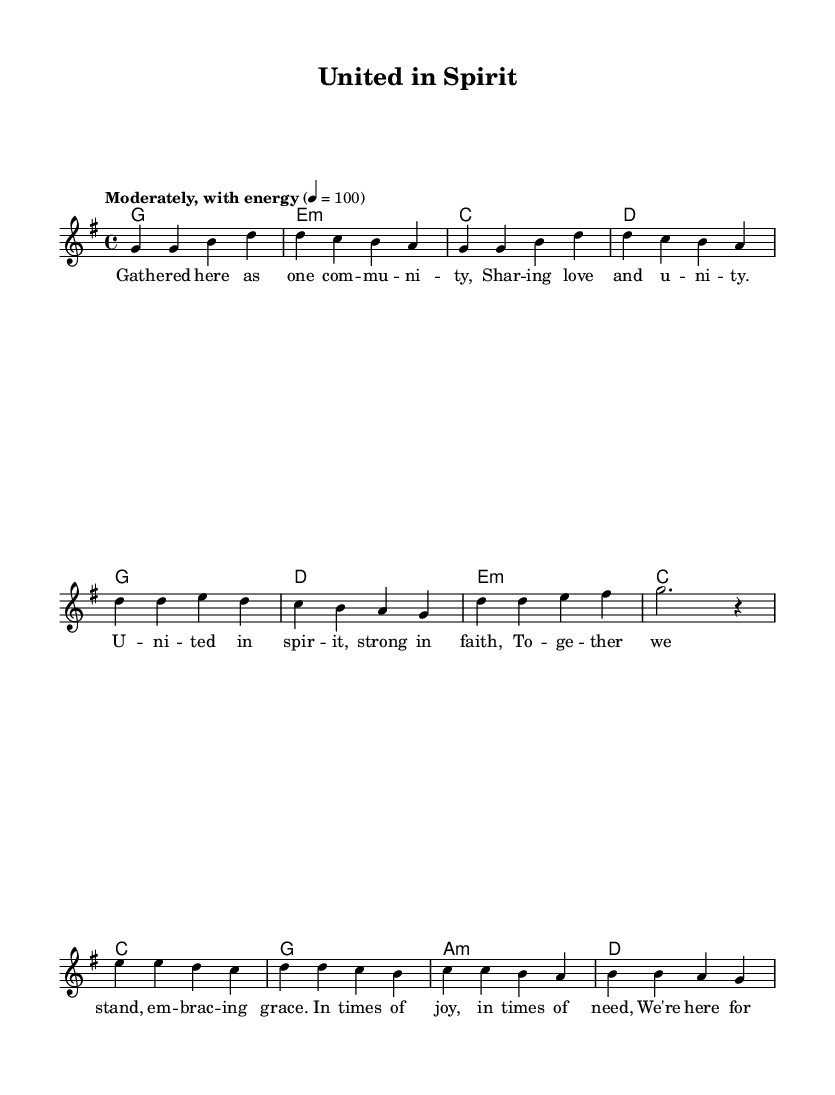What is the key signature of this music? The key signature is G major, which has one sharp (F#).
Answer: G major What is the time signature of this piece? The time signature is 4/4, indicating four beats per measure.
Answer: 4/4 What is the tempo marking for this piece? The tempo marking indicates a moderately energetic pace of 100 beats per minute.
Answer: Moderately, with energy How many measures are there in the verse? There are four measures in the verse section of the music.
Answer: Four What is the first word of the lyrics? The first word of the lyrics is "Gathered," starting the verse with the line "Gathered here as one community."
Answer: Gathered What chord is played in the first measure? The chord in the first measure is G major, indicated by the notation in the harmonies.
Answer: G What thematic element is emphasized in the lyrics? The thematic element emphasized is community and unity, as expressed in the lines about sharing love and embracing grace.
Answer: Community and unity 